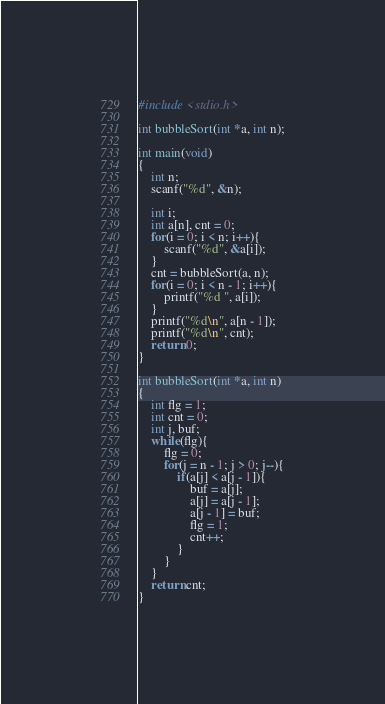<code> <loc_0><loc_0><loc_500><loc_500><_C_>
#include <stdio.h>

int bubbleSort(int *a, int n);

int main(void)
{
	int n;
	scanf("%d", &n);

	int i;
	int a[n], cnt = 0;
	for(i = 0; i < n; i++){
		scanf("%d", &a[i]);
	}
	cnt = bubbleSort(a, n);
	for(i = 0; i < n - 1; i++){
		printf("%d ", a[i]);
	}
	printf("%d\n", a[n - 1]);
	printf("%d\n", cnt);
	return 0;
}

int bubbleSort(int *a, int n)
{
	int flg = 1;
	int cnt = 0;
	int j, buf;
	while(flg){
		flg = 0;
		for(j = n - 1; j > 0; j--){
			if(a[j] < a[j - 1]){
				buf = a[j];
				a[j] = a[j - 1];
				a[j - 1] = buf;
				flg = 1;
				cnt++;
			}
		}
	}
	return cnt;
}


</code> 